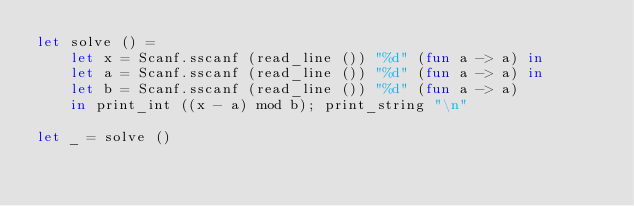<code> <loc_0><loc_0><loc_500><loc_500><_OCaml_>let solve () = 
    let x = Scanf.sscanf (read_line ()) "%d" (fun a -> a) in
    let a = Scanf.sscanf (read_line ()) "%d" (fun a -> a) in
    let b = Scanf.sscanf (read_line ()) "%d" (fun a -> a) 
    in print_int ((x - a) mod b); print_string "\n"

let _ = solve ()</code> 